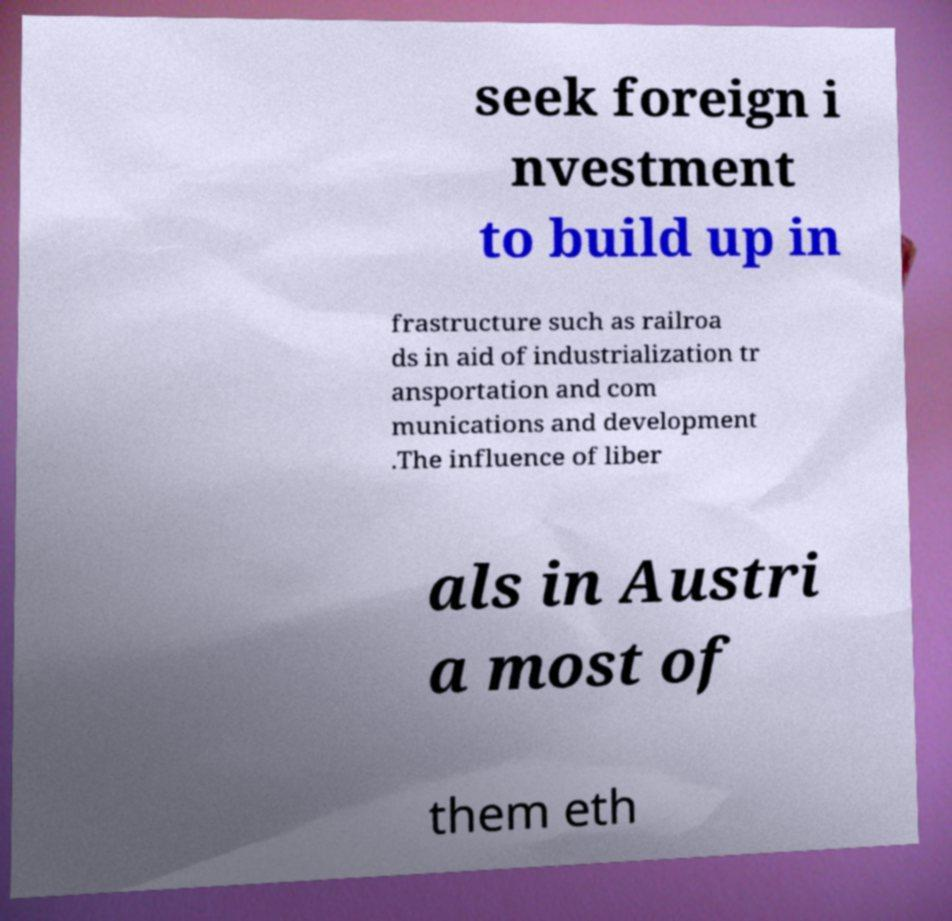Could you extract and type out the text from this image? seek foreign i nvestment to build up in frastructure such as railroa ds in aid of industrialization tr ansportation and com munications and development .The influence of liber als in Austri a most of them eth 